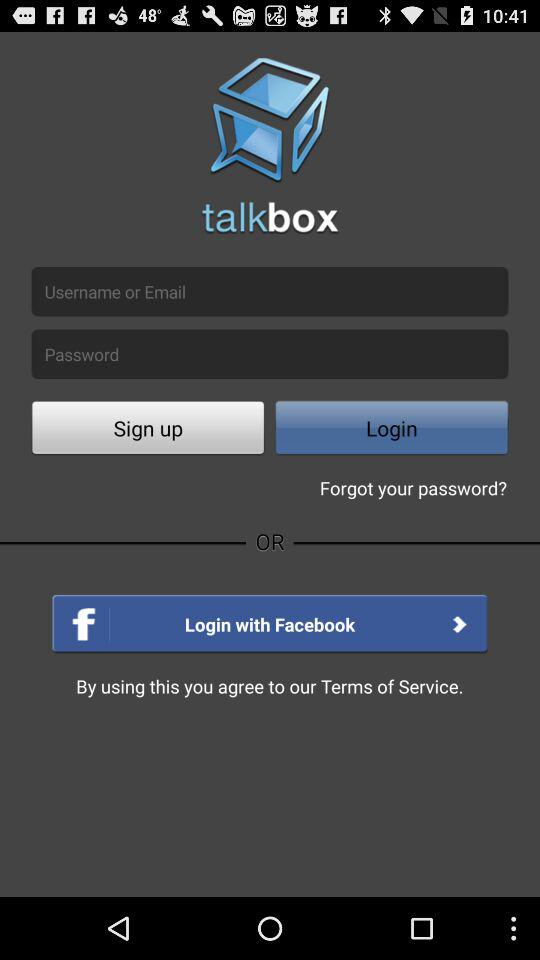What is the name of the application? The name of the application shown in the image is 'talkbox.' This app appears to offer options for user login through traditional registration or via Facebook, indicating its connectivity with social media platforms for ease of access and user integration. 